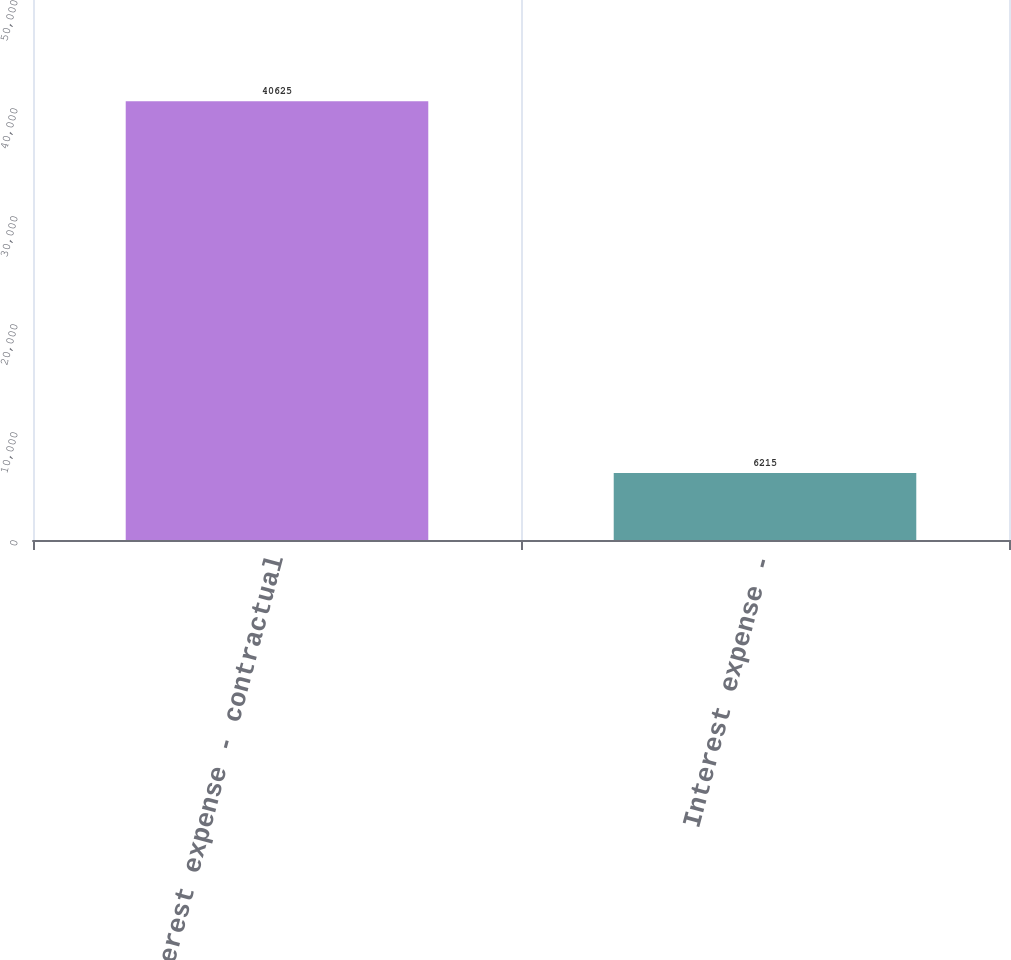Convert chart. <chart><loc_0><loc_0><loc_500><loc_500><bar_chart><fcel>Interest expense - contractual<fcel>Interest expense -<nl><fcel>40625<fcel>6215<nl></chart> 